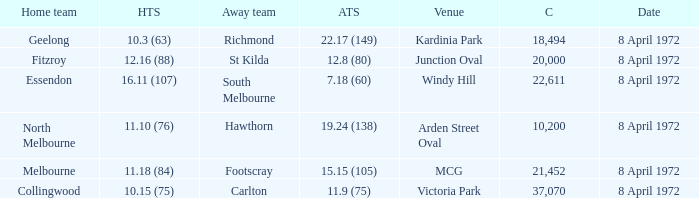Which Home team score has a Home team of geelong? 10.3 (63). 